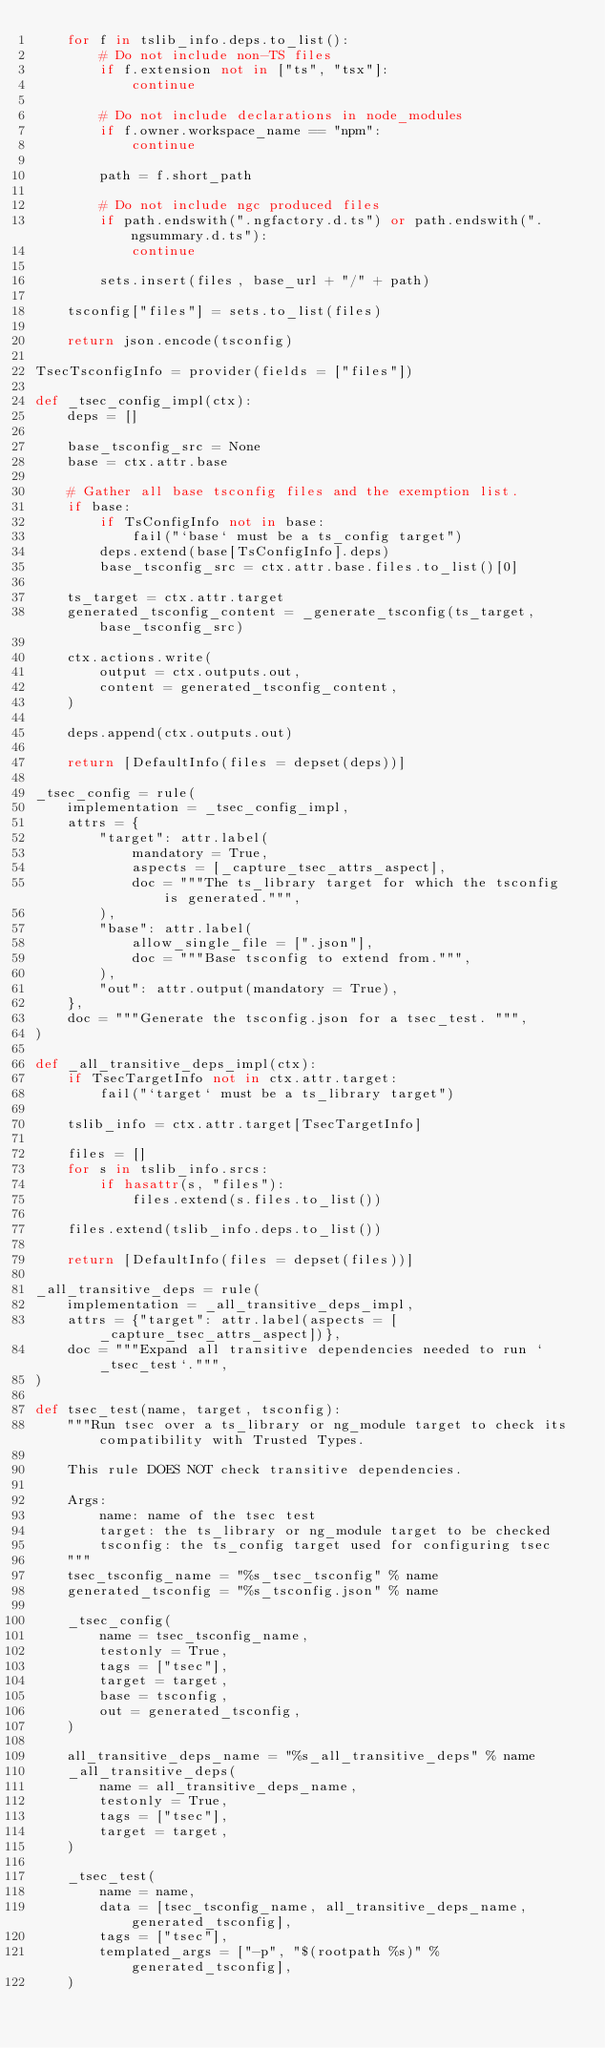<code> <loc_0><loc_0><loc_500><loc_500><_Python_>    for f in tslib_info.deps.to_list():
        # Do not include non-TS files
        if f.extension not in ["ts", "tsx"]:
            continue

        # Do not include declarations in node_modules
        if f.owner.workspace_name == "npm":
            continue

        path = f.short_path

        # Do not include ngc produced files
        if path.endswith(".ngfactory.d.ts") or path.endswith(".ngsummary.d.ts"):
            continue

        sets.insert(files, base_url + "/" + path)

    tsconfig["files"] = sets.to_list(files)

    return json.encode(tsconfig)

TsecTsconfigInfo = provider(fields = ["files"])

def _tsec_config_impl(ctx):
    deps = []

    base_tsconfig_src = None
    base = ctx.attr.base

    # Gather all base tsconfig files and the exemption list.
    if base:
        if TsConfigInfo not in base:
            fail("`base` must be a ts_config target")
        deps.extend(base[TsConfigInfo].deps)
        base_tsconfig_src = ctx.attr.base.files.to_list()[0]

    ts_target = ctx.attr.target
    generated_tsconfig_content = _generate_tsconfig(ts_target, base_tsconfig_src)

    ctx.actions.write(
        output = ctx.outputs.out,
        content = generated_tsconfig_content,
    )

    deps.append(ctx.outputs.out)

    return [DefaultInfo(files = depset(deps))]

_tsec_config = rule(
    implementation = _tsec_config_impl,
    attrs = {
        "target": attr.label(
            mandatory = True,
            aspects = [_capture_tsec_attrs_aspect],
            doc = """The ts_library target for which the tsconfig is generated.""",
        ),
        "base": attr.label(
            allow_single_file = [".json"],
            doc = """Base tsconfig to extend from.""",
        ),
        "out": attr.output(mandatory = True),
    },
    doc = """Generate the tsconfig.json for a tsec_test. """,
)

def _all_transitive_deps_impl(ctx):
    if TsecTargetInfo not in ctx.attr.target:
        fail("`target` must be a ts_library target")

    tslib_info = ctx.attr.target[TsecTargetInfo]

    files = []
    for s in tslib_info.srcs:
        if hasattr(s, "files"):
            files.extend(s.files.to_list())

    files.extend(tslib_info.deps.to_list())

    return [DefaultInfo(files = depset(files))]

_all_transitive_deps = rule(
    implementation = _all_transitive_deps_impl,
    attrs = {"target": attr.label(aspects = [_capture_tsec_attrs_aspect])},
    doc = """Expand all transitive dependencies needed to run `_tsec_test`.""",
)

def tsec_test(name, target, tsconfig):
    """Run tsec over a ts_library or ng_module target to check its compatibility with Trusted Types.

    This rule DOES NOT check transitive dependencies.

    Args:
        name: name of the tsec test
        target: the ts_library or ng_module target to be checked
        tsconfig: the ts_config target used for configuring tsec
    """
    tsec_tsconfig_name = "%s_tsec_tsconfig" % name
    generated_tsconfig = "%s_tsconfig.json" % name

    _tsec_config(
        name = tsec_tsconfig_name,
        testonly = True,
        tags = ["tsec"],
        target = target,
        base = tsconfig,
        out = generated_tsconfig,
    )

    all_transitive_deps_name = "%s_all_transitive_deps" % name
    _all_transitive_deps(
        name = all_transitive_deps_name,
        testonly = True,
        tags = ["tsec"],
        target = target,
    )

    _tsec_test(
        name = name,
        data = [tsec_tsconfig_name, all_transitive_deps_name, generated_tsconfig],
        tags = ["tsec"],
        templated_args = ["-p", "$(rootpath %s)" % generated_tsconfig],
    )
</code> 